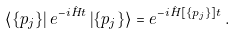Convert formula to latex. <formula><loc_0><loc_0><loc_500><loc_500>\left \langle \{ p _ { j } \} \right | e ^ { - i \hat { H } t } \left | \{ p _ { j } \} \right \rangle = e ^ { - i \hat { H } [ \{ p _ { j } \} ] t } \, .</formula> 